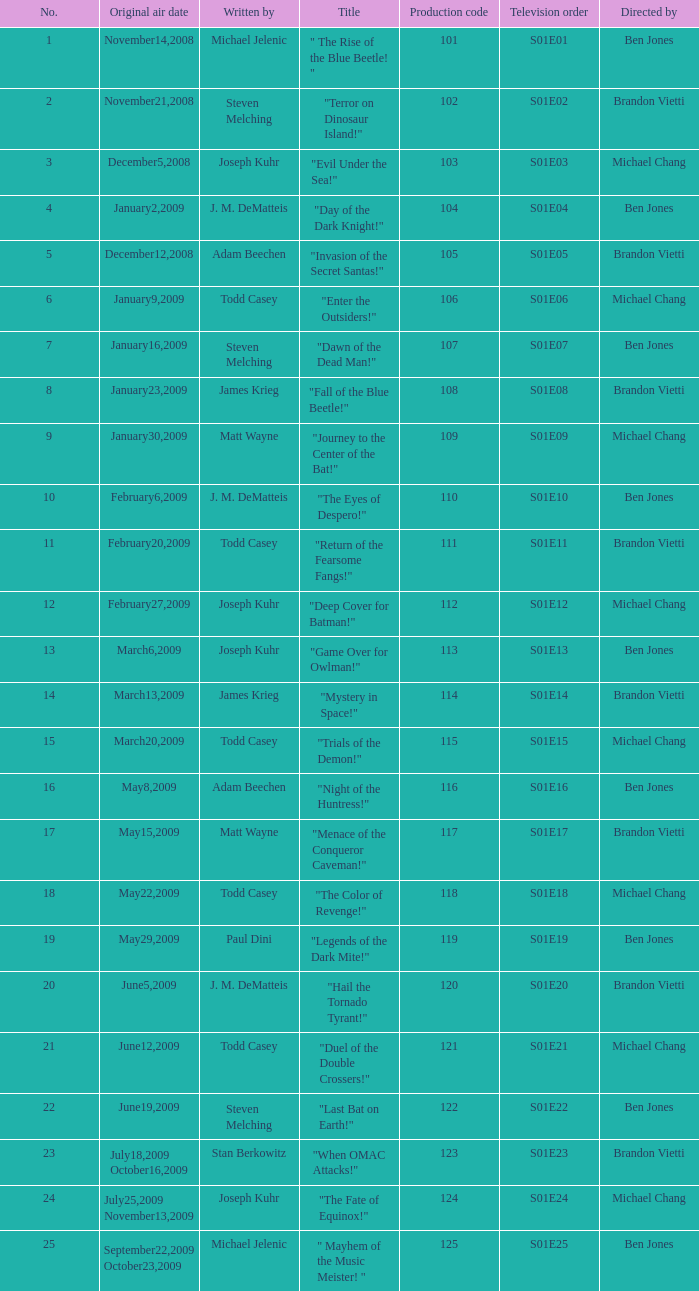Who wrote s01e06 Todd Casey. 